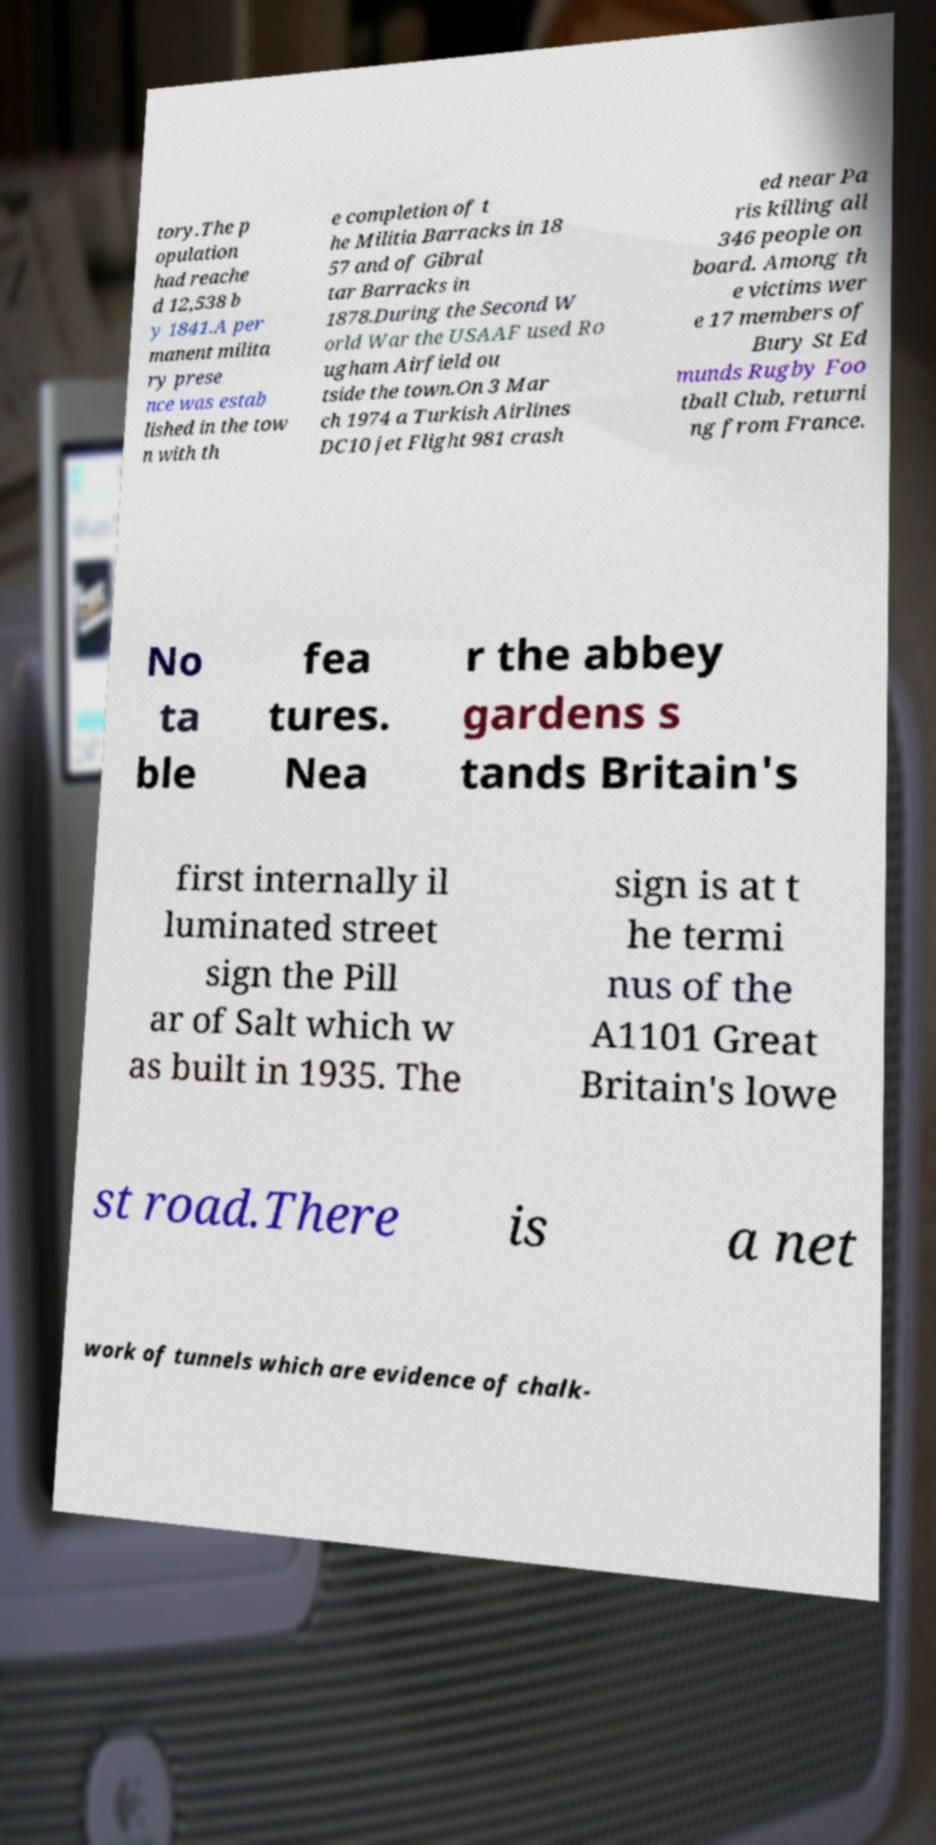There's text embedded in this image that I need extracted. Can you transcribe it verbatim? tory.The p opulation had reache d 12,538 b y 1841.A per manent milita ry prese nce was estab lished in the tow n with th e completion of t he Militia Barracks in 18 57 and of Gibral tar Barracks in 1878.During the Second W orld War the USAAF used Ro ugham Airfield ou tside the town.On 3 Mar ch 1974 a Turkish Airlines DC10 jet Flight 981 crash ed near Pa ris killing all 346 people on board. Among th e victims wer e 17 members of Bury St Ed munds Rugby Foo tball Club, returni ng from France. No ta ble fea tures. Nea r the abbey gardens s tands Britain's first internally il luminated street sign the Pill ar of Salt which w as built in 1935. The sign is at t he termi nus of the A1101 Great Britain's lowe st road.There is a net work of tunnels which are evidence of chalk- 